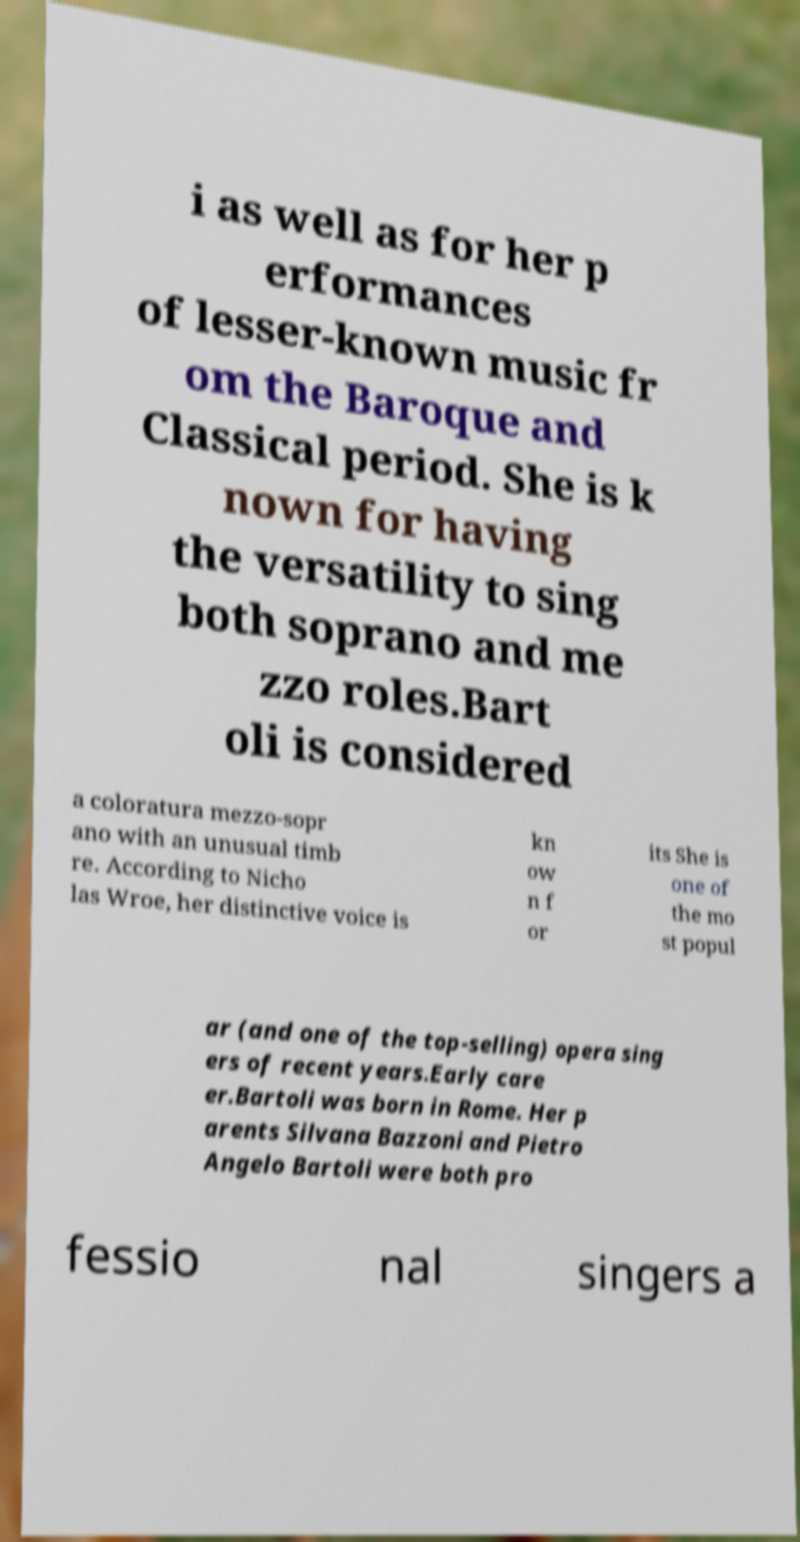Can you read and provide the text displayed in the image?This photo seems to have some interesting text. Can you extract and type it out for me? i as well as for her p erformances of lesser-known music fr om the Baroque and Classical period. She is k nown for having the versatility to sing both soprano and me zzo roles.Bart oli is considered a coloratura mezzo-sopr ano with an unusual timb re. According to Nicho las Wroe, her distinctive voice is kn ow n f or its She is one of the mo st popul ar (and one of the top-selling) opera sing ers of recent years.Early care er.Bartoli was born in Rome. Her p arents Silvana Bazzoni and Pietro Angelo Bartoli were both pro fessio nal singers a 